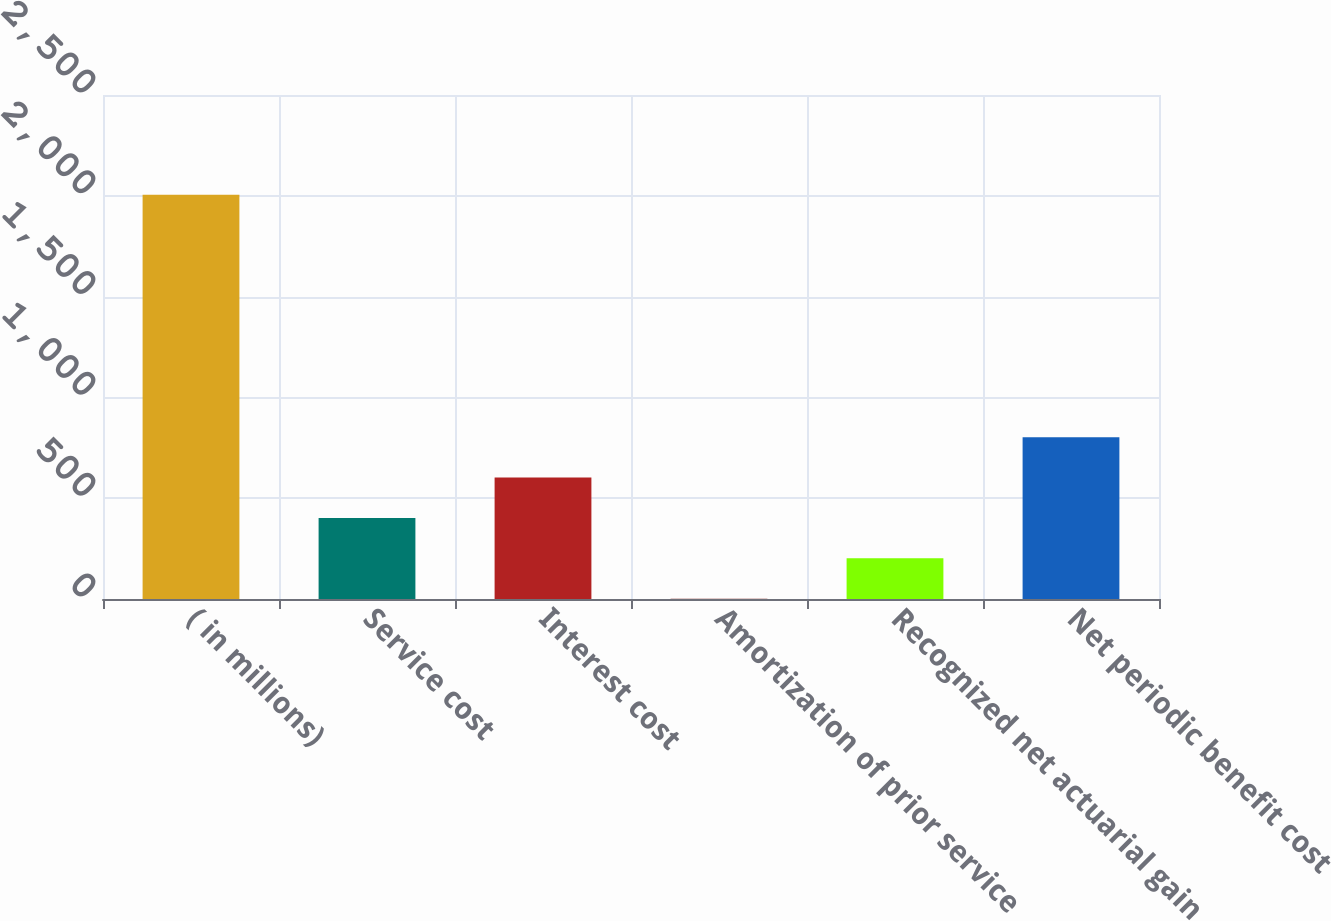<chart> <loc_0><loc_0><loc_500><loc_500><bar_chart><fcel>( in millions)<fcel>Service cost<fcel>Interest cost<fcel>Amortization of prior service<fcel>Recognized net actuarial gain<fcel>Net periodic benefit cost<nl><fcel>2005<fcel>402.2<fcel>602.55<fcel>1.5<fcel>201.85<fcel>802.9<nl></chart> 